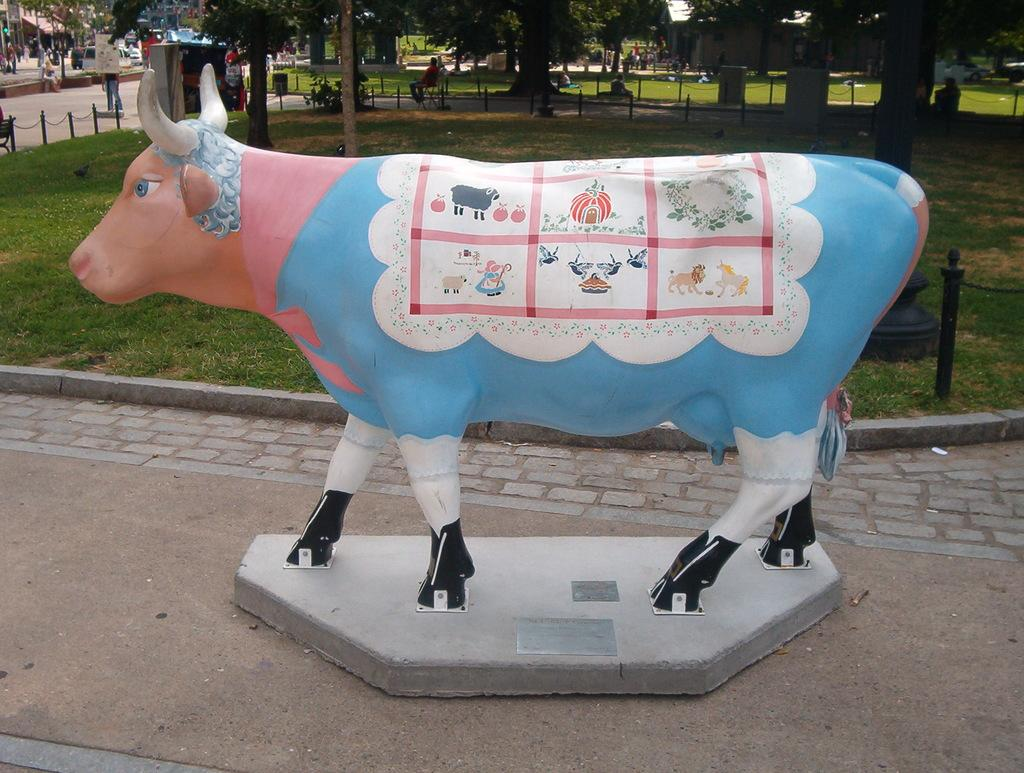What is the main subject of the image? There is a statue of a cow in the image. What can be observed on the statue? The statue has images on it. What type of vegetation is visible in the background of the image? There are trees in the background of the image. What is the ground made of in the image? There is grass on the ground in the image. What type of government is depicted in the statue's images? The statue's images do not depict any form of government; they are not mentioned in the provided facts. What type of fork can be seen in the image? There is no fork present in the image. 